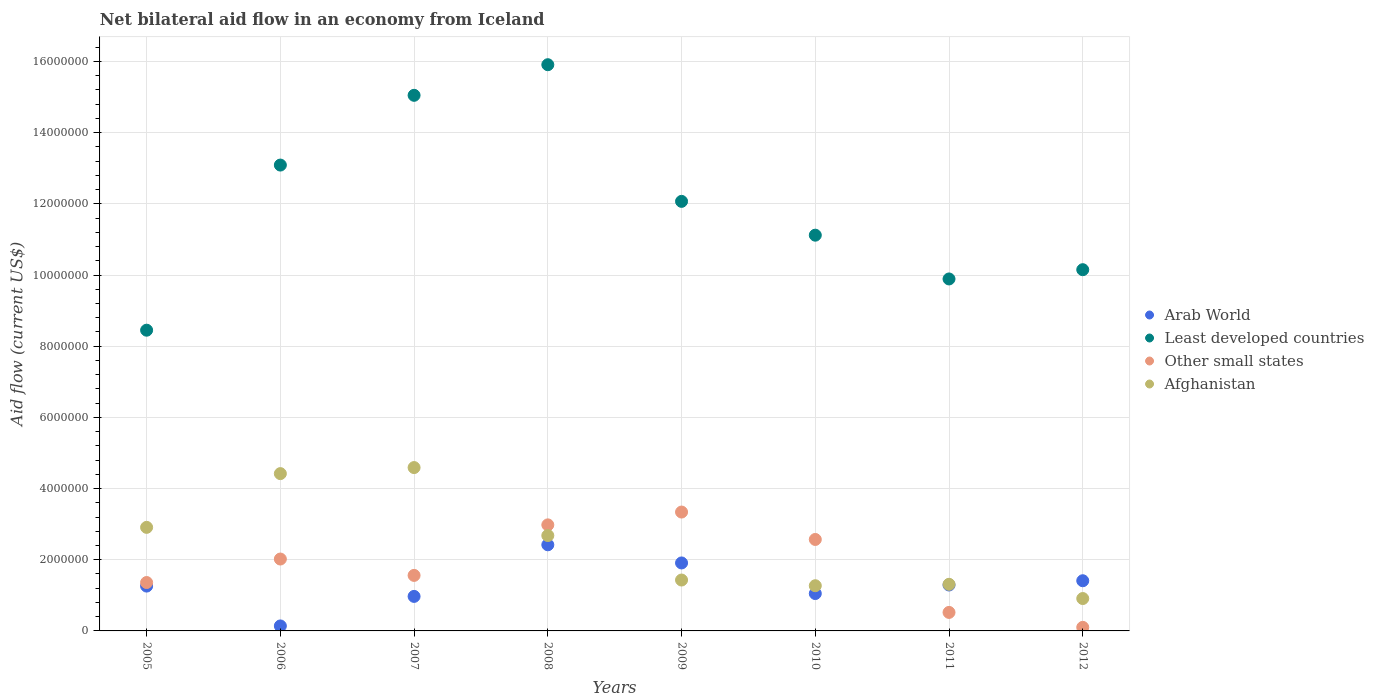How many different coloured dotlines are there?
Make the answer very short. 4. What is the net bilateral aid flow in Other small states in 2008?
Keep it short and to the point. 2.98e+06. Across all years, what is the maximum net bilateral aid flow in Afghanistan?
Keep it short and to the point. 4.59e+06. Across all years, what is the minimum net bilateral aid flow in Other small states?
Your response must be concise. 1.00e+05. In which year was the net bilateral aid flow in Afghanistan minimum?
Give a very brief answer. 2012. What is the total net bilateral aid flow in Other small states in the graph?
Provide a succinct answer. 1.44e+07. What is the difference between the net bilateral aid flow in Other small states in 2005 and that in 2009?
Your answer should be compact. -1.98e+06. What is the difference between the net bilateral aid flow in Afghanistan in 2009 and the net bilateral aid flow in Least developed countries in 2007?
Your response must be concise. -1.36e+07. What is the average net bilateral aid flow in Afghanistan per year?
Your answer should be compact. 2.44e+06. What is the ratio of the net bilateral aid flow in Arab World in 2009 to that in 2012?
Provide a short and direct response. 1.35. What is the difference between the highest and the second highest net bilateral aid flow in Arab World?
Your response must be concise. 5.10e+05. What is the difference between the highest and the lowest net bilateral aid flow in Least developed countries?
Make the answer very short. 7.46e+06. Is the sum of the net bilateral aid flow in Least developed countries in 2008 and 2009 greater than the maximum net bilateral aid flow in Afghanistan across all years?
Keep it short and to the point. Yes. Is it the case that in every year, the sum of the net bilateral aid flow in Other small states and net bilateral aid flow in Arab World  is greater than the sum of net bilateral aid flow in Afghanistan and net bilateral aid flow in Least developed countries?
Keep it short and to the point. No. Is it the case that in every year, the sum of the net bilateral aid flow in Afghanistan and net bilateral aid flow in Arab World  is greater than the net bilateral aid flow in Least developed countries?
Provide a succinct answer. No. Does the net bilateral aid flow in Afghanistan monotonically increase over the years?
Provide a short and direct response. No. Is the net bilateral aid flow in Arab World strictly less than the net bilateral aid flow in Least developed countries over the years?
Ensure brevity in your answer.  Yes. How many dotlines are there?
Offer a very short reply. 4. How many years are there in the graph?
Keep it short and to the point. 8. What is the difference between two consecutive major ticks on the Y-axis?
Your answer should be compact. 2.00e+06. Does the graph contain any zero values?
Provide a succinct answer. No. What is the title of the graph?
Provide a succinct answer. Net bilateral aid flow in an economy from Iceland. What is the label or title of the X-axis?
Give a very brief answer. Years. What is the Aid flow (current US$) in Arab World in 2005?
Your answer should be compact. 1.26e+06. What is the Aid flow (current US$) in Least developed countries in 2005?
Offer a terse response. 8.45e+06. What is the Aid flow (current US$) of Other small states in 2005?
Offer a terse response. 1.36e+06. What is the Aid flow (current US$) of Afghanistan in 2005?
Your answer should be very brief. 2.91e+06. What is the Aid flow (current US$) of Arab World in 2006?
Your answer should be very brief. 1.40e+05. What is the Aid flow (current US$) of Least developed countries in 2006?
Your answer should be compact. 1.31e+07. What is the Aid flow (current US$) of Other small states in 2006?
Your response must be concise. 2.02e+06. What is the Aid flow (current US$) of Afghanistan in 2006?
Provide a succinct answer. 4.42e+06. What is the Aid flow (current US$) of Arab World in 2007?
Your answer should be compact. 9.70e+05. What is the Aid flow (current US$) of Least developed countries in 2007?
Keep it short and to the point. 1.50e+07. What is the Aid flow (current US$) of Other small states in 2007?
Offer a very short reply. 1.56e+06. What is the Aid flow (current US$) of Afghanistan in 2007?
Keep it short and to the point. 4.59e+06. What is the Aid flow (current US$) of Arab World in 2008?
Ensure brevity in your answer.  2.42e+06. What is the Aid flow (current US$) of Least developed countries in 2008?
Provide a short and direct response. 1.59e+07. What is the Aid flow (current US$) in Other small states in 2008?
Keep it short and to the point. 2.98e+06. What is the Aid flow (current US$) in Afghanistan in 2008?
Offer a very short reply. 2.68e+06. What is the Aid flow (current US$) in Arab World in 2009?
Provide a succinct answer. 1.91e+06. What is the Aid flow (current US$) in Least developed countries in 2009?
Provide a succinct answer. 1.21e+07. What is the Aid flow (current US$) of Other small states in 2009?
Keep it short and to the point. 3.34e+06. What is the Aid flow (current US$) in Afghanistan in 2009?
Give a very brief answer. 1.43e+06. What is the Aid flow (current US$) of Arab World in 2010?
Give a very brief answer. 1.05e+06. What is the Aid flow (current US$) of Least developed countries in 2010?
Give a very brief answer. 1.11e+07. What is the Aid flow (current US$) of Other small states in 2010?
Give a very brief answer. 2.57e+06. What is the Aid flow (current US$) in Afghanistan in 2010?
Your response must be concise. 1.27e+06. What is the Aid flow (current US$) in Arab World in 2011?
Ensure brevity in your answer.  1.29e+06. What is the Aid flow (current US$) of Least developed countries in 2011?
Provide a short and direct response. 9.89e+06. What is the Aid flow (current US$) of Other small states in 2011?
Offer a terse response. 5.20e+05. What is the Aid flow (current US$) of Afghanistan in 2011?
Keep it short and to the point. 1.31e+06. What is the Aid flow (current US$) in Arab World in 2012?
Provide a succinct answer. 1.41e+06. What is the Aid flow (current US$) in Least developed countries in 2012?
Give a very brief answer. 1.02e+07. What is the Aid flow (current US$) in Other small states in 2012?
Provide a succinct answer. 1.00e+05. What is the Aid flow (current US$) of Afghanistan in 2012?
Provide a short and direct response. 9.10e+05. Across all years, what is the maximum Aid flow (current US$) of Arab World?
Make the answer very short. 2.42e+06. Across all years, what is the maximum Aid flow (current US$) in Least developed countries?
Your answer should be very brief. 1.59e+07. Across all years, what is the maximum Aid flow (current US$) of Other small states?
Ensure brevity in your answer.  3.34e+06. Across all years, what is the maximum Aid flow (current US$) in Afghanistan?
Make the answer very short. 4.59e+06. Across all years, what is the minimum Aid flow (current US$) of Least developed countries?
Your response must be concise. 8.45e+06. Across all years, what is the minimum Aid flow (current US$) in Other small states?
Provide a short and direct response. 1.00e+05. Across all years, what is the minimum Aid flow (current US$) in Afghanistan?
Your response must be concise. 9.10e+05. What is the total Aid flow (current US$) of Arab World in the graph?
Provide a succinct answer. 1.04e+07. What is the total Aid flow (current US$) of Least developed countries in the graph?
Provide a succinct answer. 9.57e+07. What is the total Aid flow (current US$) of Other small states in the graph?
Give a very brief answer. 1.44e+07. What is the total Aid flow (current US$) in Afghanistan in the graph?
Your answer should be very brief. 1.95e+07. What is the difference between the Aid flow (current US$) of Arab World in 2005 and that in 2006?
Your response must be concise. 1.12e+06. What is the difference between the Aid flow (current US$) in Least developed countries in 2005 and that in 2006?
Your response must be concise. -4.64e+06. What is the difference between the Aid flow (current US$) of Other small states in 2005 and that in 2006?
Make the answer very short. -6.60e+05. What is the difference between the Aid flow (current US$) in Afghanistan in 2005 and that in 2006?
Keep it short and to the point. -1.51e+06. What is the difference between the Aid flow (current US$) in Least developed countries in 2005 and that in 2007?
Provide a succinct answer. -6.60e+06. What is the difference between the Aid flow (current US$) in Afghanistan in 2005 and that in 2007?
Make the answer very short. -1.68e+06. What is the difference between the Aid flow (current US$) of Arab World in 2005 and that in 2008?
Ensure brevity in your answer.  -1.16e+06. What is the difference between the Aid flow (current US$) of Least developed countries in 2005 and that in 2008?
Ensure brevity in your answer.  -7.46e+06. What is the difference between the Aid flow (current US$) in Other small states in 2005 and that in 2008?
Provide a succinct answer. -1.62e+06. What is the difference between the Aid flow (current US$) of Arab World in 2005 and that in 2009?
Give a very brief answer. -6.50e+05. What is the difference between the Aid flow (current US$) in Least developed countries in 2005 and that in 2009?
Give a very brief answer. -3.62e+06. What is the difference between the Aid flow (current US$) of Other small states in 2005 and that in 2009?
Your answer should be very brief. -1.98e+06. What is the difference between the Aid flow (current US$) of Afghanistan in 2005 and that in 2009?
Your answer should be compact. 1.48e+06. What is the difference between the Aid flow (current US$) in Arab World in 2005 and that in 2010?
Your response must be concise. 2.10e+05. What is the difference between the Aid flow (current US$) of Least developed countries in 2005 and that in 2010?
Give a very brief answer. -2.67e+06. What is the difference between the Aid flow (current US$) of Other small states in 2005 and that in 2010?
Give a very brief answer. -1.21e+06. What is the difference between the Aid flow (current US$) of Afghanistan in 2005 and that in 2010?
Provide a short and direct response. 1.64e+06. What is the difference between the Aid flow (current US$) in Arab World in 2005 and that in 2011?
Make the answer very short. -3.00e+04. What is the difference between the Aid flow (current US$) of Least developed countries in 2005 and that in 2011?
Provide a succinct answer. -1.44e+06. What is the difference between the Aid flow (current US$) in Other small states in 2005 and that in 2011?
Your response must be concise. 8.40e+05. What is the difference between the Aid flow (current US$) of Afghanistan in 2005 and that in 2011?
Make the answer very short. 1.60e+06. What is the difference between the Aid flow (current US$) in Least developed countries in 2005 and that in 2012?
Ensure brevity in your answer.  -1.70e+06. What is the difference between the Aid flow (current US$) in Other small states in 2005 and that in 2012?
Your response must be concise. 1.26e+06. What is the difference between the Aid flow (current US$) in Arab World in 2006 and that in 2007?
Offer a very short reply. -8.30e+05. What is the difference between the Aid flow (current US$) in Least developed countries in 2006 and that in 2007?
Offer a very short reply. -1.96e+06. What is the difference between the Aid flow (current US$) in Other small states in 2006 and that in 2007?
Your response must be concise. 4.60e+05. What is the difference between the Aid flow (current US$) in Afghanistan in 2006 and that in 2007?
Your answer should be very brief. -1.70e+05. What is the difference between the Aid flow (current US$) of Arab World in 2006 and that in 2008?
Offer a terse response. -2.28e+06. What is the difference between the Aid flow (current US$) of Least developed countries in 2006 and that in 2008?
Give a very brief answer. -2.82e+06. What is the difference between the Aid flow (current US$) of Other small states in 2006 and that in 2008?
Offer a very short reply. -9.60e+05. What is the difference between the Aid flow (current US$) in Afghanistan in 2006 and that in 2008?
Provide a short and direct response. 1.74e+06. What is the difference between the Aid flow (current US$) in Arab World in 2006 and that in 2009?
Give a very brief answer. -1.77e+06. What is the difference between the Aid flow (current US$) of Least developed countries in 2006 and that in 2009?
Offer a very short reply. 1.02e+06. What is the difference between the Aid flow (current US$) of Other small states in 2006 and that in 2009?
Make the answer very short. -1.32e+06. What is the difference between the Aid flow (current US$) of Afghanistan in 2006 and that in 2009?
Keep it short and to the point. 2.99e+06. What is the difference between the Aid flow (current US$) of Arab World in 2006 and that in 2010?
Provide a succinct answer. -9.10e+05. What is the difference between the Aid flow (current US$) of Least developed countries in 2006 and that in 2010?
Your answer should be compact. 1.97e+06. What is the difference between the Aid flow (current US$) of Other small states in 2006 and that in 2010?
Keep it short and to the point. -5.50e+05. What is the difference between the Aid flow (current US$) in Afghanistan in 2006 and that in 2010?
Offer a very short reply. 3.15e+06. What is the difference between the Aid flow (current US$) in Arab World in 2006 and that in 2011?
Ensure brevity in your answer.  -1.15e+06. What is the difference between the Aid flow (current US$) in Least developed countries in 2006 and that in 2011?
Make the answer very short. 3.20e+06. What is the difference between the Aid flow (current US$) in Other small states in 2006 and that in 2011?
Keep it short and to the point. 1.50e+06. What is the difference between the Aid flow (current US$) of Afghanistan in 2006 and that in 2011?
Give a very brief answer. 3.11e+06. What is the difference between the Aid flow (current US$) of Arab World in 2006 and that in 2012?
Ensure brevity in your answer.  -1.27e+06. What is the difference between the Aid flow (current US$) in Least developed countries in 2006 and that in 2012?
Provide a short and direct response. 2.94e+06. What is the difference between the Aid flow (current US$) of Other small states in 2006 and that in 2012?
Your response must be concise. 1.92e+06. What is the difference between the Aid flow (current US$) in Afghanistan in 2006 and that in 2012?
Ensure brevity in your answer.  3.51e+06. What is the difference between the Aid flow (current US$) in Arab World in 2007 and that in 2008?
Your answer should be compact. -1.45e+06. What is the difference between the Aid flow (current US$) in Least developed countries in 2007 and that in 2008?
Provide a short and direct response. -8.60e+05. What is the difference between the Aid flow (current US$) in Other small states in 2007 and that in 2008?
Your response must be concise. -1.42e+06. What is the difference between the Aid flow (current US$) in Afghanistan in 2007 and that in 2008?
Offer a very short reply. 1.91e+06. What is the difference between the Aid flow (current US$) in Arab World in 2007 and that in 2009?
Offer a very short reply. -9.40e+05. What is the difference between the Aid flow (current US$) of Least developed countries in 2007 and that in 2009?
Offer a terse response. 2.98e+06. What is the difference between the Aid flow (current US$) in Other small states in 2007 and that in 2009?
Ensure brevity in your answer.  -1.78e+06. What is the difference between the Aid flow (current US$) of Afghanistan in 2007 and that in 2009?
Make the answer very short. 3.16e+06. What is the difference between the Aid flow (current US$) in Arab World in 2007 and that in 2010?
Your answer should be very brief. -8.00e+04. What is the difference between the Aid flow (current US$) of Least developed countries in 2007 and that in 2010?
Ensure brevity in your answer.  3.93e+06. What is the difference between the Aid flow (current US$) in Other small states in 2007 and that in 2010?
Give a very brief answer. -1.01e+06. What is the difference between the Aid flow (current US$) in Afghanistan in 2007 and that in 2010?
Your answer should be very brief. 3.32e+06. What is the difference between the Aid flow (current US$) in Arab World in 2007 and that in 2011?
Offer a very short reply. -3.20e+05. What is the difference between the Aid flow (current US$) of Least developed countries in 2007 and that in 2011?
Your answer should be compact. 5.16e+06. What is the difference between the Aid flow (current US$) of Other small states in 2007 and that in 2011?
Your answer should be compact. 1.04e+06. What is the difference between the Aid flow (current US$) of Afghanistan in 2007 and that in 2011?
Offer a very short reply. 3.28e+06. What is the difference between the Aid flow (current US$) in Arab World in 2007 and that in 2012?
Ensure brevity in your answer.  -4.40e+05. What is the difference between the Aid flow (current US$) in Least developed countries in 2007 and that in 2012?
Keep it short and to the point. 4.90e+06. What is the difference between the Aid flow (current US$) in Other small states in 2007 and that in 2012?
Offer a terse response. 1.46e+06. What is the difference between the Aid flow (current US$) of Afghanistan in 2007 and that in 2012?
Your response must be concise. 3.68e+06. What is the difference between the Aid flow (current US$) of Arab World in 2008 and that in 2009?
Offer a terse response. 5.10e+05. What is the difference between the Aid flow (current US$) of Least developed countries in 2008 and that in 2009?
Your response must be concise. 3.84e+06. What is the difference between the Aid flow (current US$) in Other small states in 2008 and that in 2009?
Provide a succinct answer. -3.60e+05. What is the difference between the Aid flow (current US$) in Afghanistan in 2008 and that in 2009?
Offer a terse response. 1.25e+06. What is the difference between the Aid flow (current US$) in Arab World in 2008 and that in 2010?
Provide a succinct answer. 1.37e+06. What is the difference between the Aid flow (current US$) of Least developed countries in 2008 and that in 2010?
Provide a succinct answer. 4.79e+06. What is the difference between the Aid flow (current US$) in Other small states in 2008 and that in 2010?
Provide a succinct answer. 4.10e+05. What is the difference between the Aid flow (current US$) of Afghanistan in 2008 and that in 2010?
Offer a very short reply. 1.41e+06. What is the difference between the Aid flow (current US$) in Arab World in 2008 and that in 2011?
Your answer should be compact. 1.13e+06. What is the difference between the Aid flow (current US$) in Least developed countries in 2008 and that in 2011?
Offer a terse response. 6.02e+06. What is the difference between the Aid flow (current US$) in Other small states in 2008 and that in 2011?
Your response must be concise. 2.46e+06. What is the difference between the Aid flow (current US$) of Afghanistan in 2008 and that in 2011?
Your response must be concise. 1.37e+06. What is the difference between the Aid flow (current US$) in Arab World in 2008 and that in 2012?
Your answer should be compact. 1.01e+06. What is the difference between the Aid flow (current US$) of Least developed countries in 2008 and that in 2012?
Give a very brief answer. 5.76e+06. What is the difference between the Aid flow (current US$) in Other small states in 2008 and that in 2012?
Provide a succinct answer. 2.88e+06. What is the difference between the Aid flow (current US$) of Afghanistan in 2008 and that in 2012?
Your answer should be compact. 1.77e+06. What is the difference between the Aid flow (current US$) of Arab World in 2009 and that in 2010?
Offer a terse response. 8.60e+05. What is the difference between the Aid flow (current US$) in Least developed countries in 2009 and that in 2010?
Your answer should be very brief. 9.50e+05. What is the difference between the Aid flow (current US$) of Other small states in 2009 and that in 2010?
Offer a very short reply. 7.70e+05. What is the difference between the Aid flow (current US$) in Arab World in 2009 and that in 2011?
Offer a very short reply. 6.20e+05. What is the difference between the Aid flow (current US$) of Least developed countries in 2009 and that in 2011?
Your answer should be very brief. 2.18e+06. What is the difference between the Aid flow (current US$) of Other small states in 2009 and that in 2011?
Provide a short and direct response. 2.82e+06. What is the difference between the Aid flow (current US$) of Least developed countries in 2009 and that in 2012?
Keep it short and to the point. 1.92e+06. What is the difference between the Aid flow (current US$) of Other small states in 2009 and that in 2012?
Ensure brevity in your answer.  3.24e+06. What is the difference between the Aid flow (current US$) in Afghanistan in 2009 and that in 2012?
Provide a succinct answer. 5.20e+05. What is the difference between the Aid flow (current US$) in Least developed countries in 2010 and that in 2011?
Offer a terse response. 1.23e+06. What is the difference between the Aid flow (current US$) of Other small states in 2010 and that in 2011?
Provide a short and direct response. 2.05e+06. What is the difference between the Aid flow (current US$) in Arab World in 2010 and that in 2012?
Your answer should be compact. -3.60e+05. What is the difference between the Aid flow (current US$) in Least developed countries in 2010 and that in 2012?
Give a very brief answer. 9.70e+05. What is the difference between the Aid flow (current US$) in Other small states in 2010 and that in 2012?
Your answer should be compact. 2.47e+06. What is the difference between the Aid flow (current US$) in Arab World in 2011 and that in 2012?
Provide a short and direct response. -1.20e+05. What is the difference between the Aid flow (current US$) in Least developed countries in 2011 and that in 2012?
Make the answer very short. -2.60e+05. What is the difference between the Aid flow (current US$) in Other small states in 2011 and that in 2012?
Provide a short and direct response. 4.20e+05. What is the difference between the Aid flow (current US$) of Arab World in 2005 and the Aid flow (current US$) of Least developed countries in 2006?
Offer a terse response. -1.18e+07. What is the difference between the Aid flow (current US$) of Arab World in 2005 and the Aid flow (current US$) of Other small states in 2006?
Make the answer very short. -7.60e+05. What is the difference between the Aid flow (current US$) of Arab World in 2005 and the Aid flow (current US$) of Afghanistan in 2006?
Ensure brevity in your answer.  -3.16e+06. What is the difference between the Aid flow (current US$) of Least developed countries in 2005 and the Aid flow (current US$) of Other small states in 2006?
Keep it short and to the point. 6.43e+06. What is the difference between the Aid flow (current US$) of Least developed countries in 2005 and the Aid flow (current US$) of Afghanistan in 2006?
Make the answer very short. 4.03e+06. What is the difference between the Aid flow (current US$) of Other small states in 2005 and the Aid flow (current US$) of Afghanistan in 2006?
Give a very brief answer. -3.06e+06. What is the difference between the Aid flow (current US$) of Arab World in 2005 and the Aid flow (current US$) of Least developed countries in 2007?
Keep it short and to the point. -1.38e+07. What is the difference between the Aid flow (current US$) in Arab World in 2005 and the Aid flow (current US$) in Other small states in 2007?
Offer a terse response. -3.00e+05. What is the difference between the Aid flow (current US$) in Arab World in 2005 and the Aid flow (current US$) in Afghanistan in 2007?
Offer a terse response. -3.33e+06. What is the difference between the Aid flow (current US$) of Least developed countries in 2005 and the Aid flow (current US$) of Other small states in 2007?
Provide a succinct answer. 6.89e+06. What is the difference between the Aid flow (current US$) of Least developed countries in 2005 and the Aid flow (current US$) of Afghanistan in 2007?
Your response must be concise. 3.86e+06. What is the difference between the Aid flow (current US$) of Other small states in 2005 and the Aid flow (current US$) of Afghanistan in 2007?
Keep it short and to the point. -3.23e+06. What is the difference between the Aid flow (current US$) of Arab World in 2005 and the Aid flow (current US$) of Least developed countries in 2008?
Make the answer very short. -1.46e+07. What is the difference between the Aid flow (current US$) in Arab World in 2005 and the Aid flow (current US$) in Other small states in 2008?
Your answer should be very brief. -1.72e+06. What is the difference between the Aid flow (current US$) in Arab World in 2005 and the Aid flow (current US$) in Afghanistan in 2008?
Your answer should be very brief. -1.42e+06. What is the difference between the Aid flow (current US$) of Least developed countries in 2005 and the Aid flow (current US$) of Other small states in 2008?
Offer a terse response. 5.47e+06. What is the difference between the Aid flow (current US$) in Least developed countries in 2005 and the Aid flow (current US$) in Afghanistan in 2008?
Offer a very short reply. 5.77e+06. What is the difference between the Aid flow (current US$) of Other small states in 2005 and the Aid flow (current US$) of Afghanistan in 2008?
Offer a very short reply. -1.32e+06. What is the difference between the Aid flow (current US$) of Arab World in 2005 and the Aid flow (current US$) of Least developed countries in 2009?
Keep it short and to the point. -1.08e+07. What is the difference between the Aid flow (current US$) of Arab World in 2005 and the Aid flow (current US$) of Other small states in 2009?
Your answer should be compact. -2.08e+06. What is the difference between the Aid flow (current US$) of Least developed countries in 2005 and the Aid flow (current US$) of Other small states in 2009?
Offer a terse response. 5.11e+06. What is the difference between the Aid flow (current US$) in Least developed countries in 2005 and the Aid flow (current US$) in Afghanistan in 2009?
Provide a short and direct response. 7.02e+06. What is the difference between the Aid flow (current US$) of Other small states in 2005 and the Aid flow (current US$) of Afghanistan in 2009?
Your response must be concise. -7.00e+04. What is the difference between the Aid flow (current US$) of Arab World in 2005 and the Aid flow (current US$) of Least developed countries in 2010?
Keep it short and to the point. -9.86e+06. What is the difference between the Aid flow (current US$) in Arab World in 2005 and the Aid flow (current US$) in Other small states in 2010?
Ensure brevity in your answer.  -1.31e+06. What is the difference between the Aid flow (current US$) in Least developed countries in 2005 and the Aid flow (current US$) in Other small states in 2010?
Your answer should be compact. 5.88e+06. What is the difference between the Aid flow (current US$) in Least developed countries in 2005 and the Aid flow (current US$) in Afghanistan in 2010?
Provide a short and direct response. 7.18e+06. What is the difference between the Aid flow (current US$) in Other small states in 2005 and the Aid flow (current US$) in Afghanistan in 2010?
Keep it short and to the point. 9.00e+04. What is the difference between the Aid flow (current US$) of Arab World in 2005 and the Aid flow (current US$) of Least developed countries in 2011?
Your response must be concise. -8.63e+06. What is the difference between the Aid flow (current US$) in Arab World in 2005 and the Aid flow (current US$) in Other small states in 2011?
Provide a succinct answer. 7.40e+05. What is the difference between the Aid flow (current US$) in Arab World in 2005 and the Aid flow (current US$) in Afghanistan in 2011?
Ensure brevity in your answer.  -5.00e+04. What is the difference between the Aid flow (current US$) of Least developed countries in 2005 and the Aid flow (current US$) of Other small states in 2011?
Your answer should be very brief. 7.93e+06. What is the difference between the Aid flow (current US$) in Least developed countries in 2005 and the Aid flow (current US$) in Afghanistan in 2011?
Give a very brief answer. 7.14e+06. What is the difference between the Aid flow (current US$) in Other small states in 2005 and the Aid flow (current US$) in Afghanistan in 2011?
Make the answer very short. 5.00e+04. What is the difference between the Aid flow (current US$) of Arab World in 2005 and the Aid flow (current US$) of Least developed countries in 2012?
Your response must be concise. -8.89e+06. What is the difference between the Aid flow (current US$) in Arab World in 2005 and the Aid flow (current US$) in Other small states in 2012?
Provide a succinct answer. 1.16e+06. What is the difference between the Aid flow (current US$) of Least developed countries in 2005 and the Aid flow (current US$) of Other small states in 2012?
Offer a very short reply. 8.35e+06. What is the difference between the Aid flow (current US$) in Least developed countries in 2005 and the Aid flow (current US$) in Afghanistan in 2012?
Your answer should be very brief. 7.54e+06. What is the difference between the Aid flow (current US$) of Arab World in 2006 and the Aid flow (current US$) of Least developed countries in 2007?
Ensure brevity in your answer.  -1.49e+07. What is the difference between the Aid flow (current US$) of Arab World in 2006 and the Aid flow (current US$) of Other small states in 2007?
Offer a very short reply. -1.42e+06. What is the difference between the Aid flow (current US$) of Arab World in 2006 and the Aid flow (current US$) of Afghanistan in 2007?
Keep it short and to the point. -4.45e+06. What is the difference between the Aid flow (current US$) of Least developed countries in 2006 and the Aid flow (current US$) of Other small states in 2007?
Keep it short and to the point. 1.15e+07. What is the difference between the Aid flow (current US$) in Least developed countries in 2006 and the Aid flow (current US$) in Afghanistan in 2007?
Offer a very short reply. 8.50e+06. What is the difference between the Aid flow (current US$) in Other small states in 2006 and the Aid flow (current US$) in Afghanistan in 2007?
Give a very brief answer. -2.57e+06. What is the difference between the Aid flow (current US$) in Arab World in 2006 and the Aid flow (current US$) in Least developed countries in 2008?
Offer a terse response. -1.58e+07. What is the difference between the Aid flow (current US$) in Arab World in 2006 and the Aid flow (current US$) in Other small states in 2008?
Give a very brief answer. -2.84e+06. What is the difference between the Aid flow (current US$) in Arab World in 2006 and the Aid flow (current US$) in Afghanistan in 2008?
Make the answer very short. -2.54e+06. What is the difference between the Aid flow (current US$) of Least developed countries in 2006 and the Aid flow (current US$) of Other small states in 2008?
Your answer should be very brief. 1.01e+07. What is the difference between the Aid flow (current US$) in Least developed countries in 2006 and the Aid flow (current US$) in Afghanistan in 2008?
Make the answer very short. 1.04e+07. What is the difference between the Aid flow (current US$) of Other small states in 2006 and the Aid flow (current US$) of Afghanistan in 2008?
Provide a succinct answer. -6.60e+05. What is the difference between the Aid flow (current US$) of Arab World in 2006 and the Aid flow (current US$) of Least developed countries in 2009?
Ensure brevity in your answer.  -1.19e+07. What is the difference between the Aid flow (current US$) in Arab World in 2006 and the Aid flow (current US$) in Other small states in 2009?
Keep it short and to the point. -3.20e+06. What is the difference between the Aid flow (current US$) in Arab World in 2006 and the Aid flow (current US$) in Afghanistan in 2009?
Offer a terse response. -1.29e+06. What is the difference between the Aid flow (current US$) in Least developed countries in 2006 and the Aid flow (current US$) in Other small states in 2009?
Your response must be concise. 9.75e+06. What is the difference between the Aid flow (current US$) of Least developed countries in 2006 and the Aid flow (current US$) of Afghanistan in 2009?
Provide a short and direct response. 1.17e+07. What is the difference between the Aid flow (current US$) in Other small states in 2006 and the Aid flow (current US$) in Afghanistan in 2009?
Offer a very short reply. 5.90e+05. What is the difference between the Aid flow (current US$) of Arab World in 2006 and the Aid flow (current US$) of Least developed countries in 2010?
Your answer should be very brief. -1.10e+07. What is the difference between the Aid flow (current US$) in Arab World in 2006 and the Aid flow (current US$) in Other small states in 2010?
Your response must be concise. -2.43e+06. What is the difference between the Aid flow (current US$) of Arab World in 2006 and the Aid flow (current US$) of Afghanistan in 2010?
Your response must be concise. -1.13e+06. What is the difference between the Aid flow (current US$) in Least developed countries in 2006 and the Aid flow (current US$) in Other small states in 2010?
Provide a short and direct response. 1.05e+07. What is the difference between the Aid flow (current US$) in Least developed countries in 2006 and the Aid flow (current US$) in Afghanistan in 2010?
Keep it short and to the point. 1.18e+07. What is the difference between the Aid flow (current US$) in Other small states in 2006 and the Aid flow (current US$) in Afghanistan in 2010?
Offer a terse response. 7.50e+05. What is the difference between the Aid flow (current US$) in Arab World in 2006 and the Aid flow (current US$) in Least developed countries in 2011?
Offer a terse response. -9.75e+06. What is the difference between the Aid flow (current US$) in Arab World in 2006 and the Aid flow (current US$) in Other small states in 2011?
Give a very brief answer. -3.80e+05. What is the difference between the Aid flow (current US$) in Arab World in 2006 and the Aid flow (current US$) in Afghanistan in 2011?
Ensure brevity in your answer.  -1.17e+06. What is the difference between the Aid flow (current US$) in Least developed countries in 2006 and the Aid flow (current US$) in Other small states in 2011?
Your response must be concise. 1.26e+07. What is the difference between the Aid flow (current US$) of Least developed countries in 2006 and the Aid flow (current US$) of Afghanistan in 2011?
Your response must be concise. 1.18e+07. What is the difference between the Aid flow (current US$) of Other small states in 2006 and the Aid flow (current US$) of Afghanistan in 2011?
Offer a terse response. 7.10e+05. What is the difference between the Aid flow (current US$) in Arab World in 2006 and the Aid flow (current US$) in Least developed countries in 2012?
Your response must be concise. -1.00e+07. What is the difference between the Aid flow (current US$) of Arab World in 2006 and the Aid flow (current US$) of Afghanistan in 2012?
Give a very brief answer. -7.70e+05. What is the difference between the Aid flow (current US$) in Least developed countries in 2006 and the Aid flow (current US$) in Other small states in 2012?
Give a very brief answer. 1.30e+07. What is the difference between the Aid flow (current US$) of Least developed countries in 2006 and the Aid flow (current US$) of Afghanistan in 2012?
Ensure brevity in your answer.  1.22e+07. What is the difference between the Aid flow (current US$) of Other small states in 2006 and the Aid flow (current US$) of Afghanistan in 2012?
Your answer should be very brief. 1.11e+06. What is the difference between the Aid flow (current US$) in Arab World in 2007 and the Aid flow (current US$) in Least developed countries in 2008?
Provide a short and direct response. -1.49e+07. What is the difference between the Aid flow (current US$) of Arab World in 2007 and the Aid flow (current US$) of Other small states in 2008?
Your answer should be compact. -2.01e+06. What is the difference between the Aid flow (current US$) of Arab World in 2007 and the Aid flow (current US$) of Afghanistan in 2008?
Your answer should be very brief. -1.71e+06. What is the difference between the Aid flow (current US$) of Least developed countries in 2007 and the Aid flow (current US$) of Other small states in 2008?
Keep it short and to the point. 1.21e+07. What is the difference between the Aid flow (current US$) of Least developed countries in 2007 and the Aid flow (current US$) of Afghanistan in 2008?
Offer a very short reply. 1.24e+07. What is the difference between the Aid flow (current US$) in Other small states in 2007 and the Aid flow (current US$) in Afghanistan in 2008?
Your response must be concise. -1.12e+06. What is the difference between the Aid flow (current US$) in Arab World in 2007 and the Aid flow (current US$) in Least developed countries in 2009?
Offer a terse response. -1.11e+07. What is the difference between the Aid flow (current US$) in Arab World in 2007 and the Aid flow (current US$) in Other small states in 2009?
Your answer should be compact. -2.37e+06. What is the difference between the Aid flow (current US$) of Arab World in 2007 and the Aid flow (current US$) of Afghanistan in 2009?
Your response must be concise. -4.60e+05. What is the difference between the Aid flow (current US$) of Least developed countries in 2007 and the Aid flow (current US$) of Other small states in 2009?
Give a very brief answer. 1.17e+07. What is the difference between the Aid flow (current US$) of Least developed countries in 2007 and the Aid flow (current US$) of Afghanistan in 2009?
Provide a succinct answer. 1.36e+07. What is the difference between the Aid flow (current US$) in Other small states in 2007 and the Aid flow (current US$) in Afghanistan in 2009?
Offer a very short reply. 1.30e+05. What is the difference between the Aid flow (current US$) of Arab World in 2007 and the Aid flow (current US$) of Least developed countries in 2010?
Ensure brevity in your answer.  -1.02e+07. What is the difference between the Aid flow (current US$) of Arab World in 2007 and the Aid flow (current US$) of Other small states in 2010?
Your response must be concise. -1.60e+06. What is the difference between the Aid flow (current US$) in Arab World in 2007 and the Aid flow (current US$) in Afghanistan in 2010?
Your answer should be very brief. -3.00e+05. What is the difference between the Aid flow (current US$) of Least developed countries in 2007 and the Aid flow (current US$) of Other small states in 2010?
Ensure brevity in your answer.  1.25e+07. What is the difference between the Aid flow (current US$) in Least developed countries in 2007 and the Aid flow (current US$) in Afghanistan in 2010?
Ensure brevity in your answer.  1.38e+07. What is the difference between the Aid flow (current US$) in Arab World in 2007 and the Aid flow (current US$) in Least developed countries in 2011?
Your answer should be very brief. -8.92e+06. What is the difference between the Aid flow (current US$) of Arab World in 2007 and the Aid flow (current US$) of Afghanistan in 2011?
Ensure brevity in your answer.  -3.40e+05. What is the difference between the Aid flow (current US$) in Least developed countries in 2007 and the Aid flow (current US$) in Other small states in 2011?
Give a very brief answer. 1.45e+07. What is the difference between the Aid flow (current US$) in Least developed countries in 2007 and the Aid flow (current US$) in Afghanistan in 2011?
Your response must be concise. 1.37e+07. What is the difference between the Aid flow (current US$) in Other small states in 2007 and the Aid flow (current US$) in Afghanistan in 2011?
Ensure brevity in your answer.  2.50e+05. What is the difference between the Aid flow (current US$) in Arab World in 2007 and the Aid flow (current US$) in Least developed countries in 2012?
Keep it short and to the point. -9.18e+06. What is the difference between the Aid flow (current US$) in Arab World in 2007 and the Aid flow (current US$) in Other small states in 2012?
Your answer should be compact. 8.70e+05. What is the difference between the Aid flow (current US$) in Least developed countries in 2007 and the Aid flow (current US$) in Other small states in 2012?
Provide a short and direct response. 1.50e+07. What is the difference between the Aid flow (current US$) of Least developed countries in 2007 and the Aid flow (current US$) of Afghanistan in 2012?
Provide a succinct answer. 1.41e+07. What is the difference between the Aid flow (current US$) of Other small states in 2007 and the Aid flow (current US$) of Afghanistan in 2012?
Provide a succinct answer. 6.50e+05. What is the difference between the Aid flow (current US$) in Arab World in 2008 and the Aid flow (current US$) in Least developed countries in 2009?
Offer a terse response. -9.65e+06. What is the difference between the Aid flow (current US$) of Arab World in 2008 and the Aid flow (current US$) of Other small states in 2009?
Ensure brevity in your answer.  -9.20e+05. What is the difference between the Aid flow (current US$) in Arab World in 2008 and the Aid flow (current US$) in Afghanistan in 2009?
Keep it short and to the point. 9.90e+05. What is the difference between the Aid flow (current US$) in Least developed countries in 2008 and the Aid flow (current US$) in Other small states in 2009?
Give a very brief answer. 1.26e+07. What is the difference between the Aid flow (current US$) of Least developed countries in 2008 and the Aid flow (current US$) of Afghanistan in 2009?
Your answer should be very brief. 1.45e+07. What is the difference between the Aid flow (current US$) in Other small states in 2008 and the Aid flow (current US$) in Afghanistan in 2009?
Offer a terse response. 1.55e+06. What is the difference between the Aid flow (current US$) of Arab World in 2008 and the Aid flow (current US$) of Least developed countries in 2010?
Ensure brevity in your answer.  -8.70e+06. What is the difference between the Aid flow (current US$) in Arab World in 2008 and the Aid flow (current US$) in Afghanistan in 2010?
Your response must be concise. 1.15e+06. What is the difference between the Aid flow (current US$) of Least developed countries in 2008 and the Aid flow (current US$) of Other small states in 2010?
Offer a very short reply. 1.33e+07. What is the difference between the Aid flow (current US$) of Least developed countries in 2008 and the Aid flow (current US$) of Afghanistan in 2010?
Offer a very short reply. 1.46e+07. What is the difference between the Aid flow (current US$) of Other small states in 2008 and the Aid flow (current US$) of Afghanistan in 2010?
Offer a very short reply. 1.71e+06. What is the difference between the Aid flow (current US$) of Arab World in 2008 and the Aid flow (current US$) of Least developed countries in 2011?
Your response must be concise. -7.47e+06. What is the difference between the Aid flow (current US$) in Arab World in 2008 and the Aid flow (current US$) in Other small states in 2011?
Provide a short and direct response. 1.90e+06. What is the difference between the Aid flow (current US$) in Arab World in 2008 and the Aid flow (current US$) in Afghanistan in 2011?
Provide a succinct answer. 1.11e+06. What is the difference between the Aid flow (current US$) in Least developed countries in 2008 and the Aid flow (current US$) in Other small states in 2011?
Give a very brief answer. 1.54e+07. What is the difference between the Aid flow (current US$) of Least developed countries in 2008 and the Aid flow (current US$) of Afghanistan in 2011?
Your response must be concise. 1.46e+07. What is the difference between the Aid flow (current US$) in Other small states in 2008 and the Aid flow (current US$) in Afghanistan in 2011?
Keep it short and to the point. 1.67e+06. What is the difference between the Aid flow (current US$) in Arab World in 2008 and the Aid flow (current US$) in Least developed countries in 2012?
Your answer should be compact. -7.73e+06. What is the difference between the Aid flow (current US$) of Arab World in 2008 and the Aid flow (current US$) of Other small states in 2012?
Offer a terse response. 2.32e+06. What is the difference between the Aid flow (current US$) of Arab World in 2008 and the Aid flow (current US$) of Afghanistan in 2012?
Provide a short and direct response. 1.51e+06. What is the difference between the Aid flow (current US$) in Least developed countries in 2008 and the Aid flow (current US$) in Other small states in 2012?
Offer a terse response. 1.58e+07. What is the difference between the Aid flow (current US$) of Least developed countries in 2008 and the Aid flow (current US$) of Afghanistan in 2012?
Make the answer very short. 1.50e+07. What is the difference between the Aid flow (current US$) of Other small states in 2008 and the Aid flow (current US$) of Afghanistan in 2012?
Give a very brief answer. 2.07e+06. What is the difference between the Aid flow (current US$) in Arab World in 2009 and the Aid flow (current US$) in Least developed countries in 2010?
Keep it short and to the point. -9.21e+06. What is the difference between the Aid flow (current US$) of Arab World in 2009 and the Aid flow (current US$) of Other small states in 2010?
Give a very brief answer. -6.60e+05. What is the difference between the Aid flow (current US$) in Arab World in 2009 and the Aid flow (current US$) in Afghanistan in 2010?
Offer a very short reply. 6.40e+05. What is the difference between the Aid flow (current US$) in Least developed countries in 2009 and the Aid flow (current US$) in Other small states in 2010?
Ensure brevity in your answer.  9.50e+06. What is the difference between the Aid flow (current US$) of Least developed countries in 2009 and the Aid flow (current US$) of Afghanistan in 2010?
Your answer should be very brief. 1.08e+07. What is the difference between the Aid flow (current US$) in Other small states in 2009 and the Aid flow (current US$) in Afghanistan in 2010?
Provide a succinct answer. 2.07e+06. What is the difference between the Aid flow (current US$) of Arab World in 2009 and the Aid flow (current US$) of Least developed countries in 2011?
Keep it short and to the point. -7.98e+06. What is the difference between the Aid flow (current US$) of Arab World in 2009 and the Aid flow (current US$) of Other small states in 2011?
Offer a very short reply. 1.39e+06. What is the difference between the Aid flow (current US$) in Arab World in 2009 and the Aid flow (current US$) in Afghanistan in 2011?
Your answer should be very brief. 6.00e+05. What is the difference between the Aid flow (current US$) in Least developed countries in 2009 and the Aid flow (current US$) in Other small states in 2011?
Your answer should be very brief. 1.16e+07. What is the difference between the Aid flow (current US$) of Least developed countries in 2009 and the Aid flow (current US$) of Afghanistan in 2011?
Your answer should be very brief. 1.08e+07. What is the difference between the Aid flow (current US$) of Other small states in 2009 and the Aid flow (current US$) of Afghanistan in 2011?
Keep it short and to the point. 2.03e+06. What is the difference between the Aid flow (current US$) in Arab World in 2009 and the Aid flow (current US$) in Least developed countries in 2012?
Offer a terse response. -8.24e+06. What is the difference between the Aid flow (current US$) of Arab World in 2009 and the Aid flow (current US$) of Other small states in 2012?
Give a very brief answer. 1.81e+06. What is the difference between the Aid flow (current US$) of Arab World in 2009 and the Aid flow (current US$) of Afghanistan in 2012?
Keep it short and to the point. 1.00e+06. What is the difference between the Aid flow (current US$) in Least developed countries in 2009 and the Aid flow (current US$) in Other small states in 2012?
Offer a very short reply. 1.20e+07. What is the difference between the Aid flow (current US$) in Least developed countries in 2009 and the Aid flow (current US$) in Afghanistan in 2012?
Give a very brief answer. 1.12e+07. What is the difference between the Aid flow (current US$) in Other small states in 2009 and the Aid flow (current US$) in Afghanistan in 2012?
Offer a terse response. 2.43e+06. What is the difference between the Aid flow (current US$) in Arab World in 2010 and the Aid flow (current US$) in Least developed countries in 2011?
Ensure brevity in your answer.  -8.84e+06. What is the difference between the Aid flow (current US$) of Arab World in 2010 and the Aid flow (current US$) of Other small states in 2011?
Your answer should be very brief. 5.30e+05. What is the difference between the Aid flow (current US$) of Arab World in 2010 and the Aid flow (current US$) of Afghanistan in 2011?
Your answer should be very brief. -2.60e+05. What is the difference between the Aid flow (current US$) in Least developed countries in 2010 and the Aid flow (current US$) in Other small states in 2011?
Offer a very short reply. 1.06e+07. What is the difference between the Aid flow (current US$) of Least developed countries in 2010 and the Aid flow (current US$) of Afghanistan in 2011?
Your answer should be very brief. 9.81e+06. What is the difference between the Aid flow (current US$) of Other small states in 2010 and the Aid flow (current US$) of Afghanistan in 2011?
Offer a very short reply. 1.26e+06. What is the difference between the Aid flow (current US$) in Arab World in 2010 and the Aid flow (current US$) in Least developed countries in 2012?
Offer a terse response. -9.10e+06. What is the difference between the Aid flow (current US$) in Arab World in 2010 and the Aid flow (current US$) in Other small states in 2012?
Ensure brevity in your answer.  9.50e+05. What is the difference between the Aid flow (current US$) of Least developed countries in 2010 and the Aid flow (current US$) of Other small states in 2012?
Provide a succinct answer. 1.10e+07. What is the difference between the Aid flow (current US$) in Least developed countries in 2010 and the Aid flow (current US$) in Afghanistan in 2012?
Your response must be concise. 1.02e+07. What is the difference between the Aid flow (current US$) of Other small states in 2010 and the Aid flow (current US$) of Afghanistan in 2012?
Give a very brief answer. 1.66e+06. What is the difference between the Aid flow (current US$) in Arab World in 2011 and the Aid flow (current US$) in Least developed countries in 2012?
Your response must be concise. -8.86e+06. What is the difference between the Aid flow (current US$) of Arab World in 2011 and the Aid flow (current US$) of Other small states in 2012?
Your answer should be very brief. 1.19e+06. What is the difference between the Aid flow (current US$) of Arab World in 2011 and the Aid flow (current US$) of Afghanistan in 2012?
Your response must be concise. 3.80e+05. What is the difference between the Aid flow (current US$) in Least developed countries in 2011 and the Aid flow (current US$) in Other small states in 2012?
Provide a short and direct response. 9.79e+06. What is the difference between the Aid flow (current US$) of Least developed countries in 2011 and the Aid flow (current US$) of Afghanistan in 2012?
Provide a succinct answer. 8.98e+06. What is the difference between the Aid flow (current US$) of Other small states in 2011 and the Aid flow (current US$) of Afghanistan in 2012?
Your answer should be compact. -3.90e+05. What is the average Aid flow (current US$) in Arab World per year?
Ensure brevity in your answer.  1.31e+06. What is the average Aid flow (current US$) of Least developed countries per year?
Make the answer very short. 1.20e+07. What is the average Aid flow (current US$) of Other small states per year?
Your response must be concise. 1.81e+06. What is the average Aid flow (current US$) in Afghanistan per year?
Make the answer very short. 2.44e+06. In the year 2005, what is the difference between the Aid flow (current US$) of Arab World and Aid flow (current US$) of Least developed countries?
Make the answer very short. -7.19e+06. In the year 2005, what is the difference between the Aid flow (current US$) in Arab World and Aid flow (current US$) in Afghanistan?
Offer a very short reply. -1.65e+06. In the year 2005, what is the difference between the Aid flow (current US$) in Least developed countries and Aid flow (current US$) in Other small states?
Offer a terse response. 7.09e+06. In the year 2005, what is the difference between the Aid flow (current US$) of Least developed countries and Aid flow (current US$) of Afghanistan?
Ensure brevity in your answer.  5.54e+06. In the year 2005, what is the difference between the Aid flow (current US$) of Other small states and Aid flow (current US$) of Afghanistan?
Keep it short and to the point. -1.55e+06. In the year 2006, what is the difference between the Aid flow (current US$) of Arab World and Aid flow (current US$) of Least developed countries?
Give a very brief answer. -1.30e+07. In the year 2006, what is the difference between the Aid flow (current US$) in Arab World and Aid flow (current US$) in Other small states?
Give a very brief answer. -1.88e+06. In the year 2006, what is the difference between the Aid flow (current US$) in Arab World and Aid flow (current US$) in Afghanistan?
Provide a succinct answer. -4.28e+06. In the year 2006, what is the difference between the Aid flow (current US$) of Least developed countries and Aid flow (current US$) of Other small states?
Provide a short and direct response. 1.11e+07. In the year 2006, what is the difference between the Aid flow (current US$) of Least developed countries and Aid flow (current US$) of Afghanistan?
Ensure brevity in your answer.  8.67e+06. In the year 2006, what is the difference between the Aid flow (current US$) of Other small states and Aid flow (current US$) of Afghanistan?
Provide a short and direct response. -2.40e+06. In the year 2007, what is the difference between the Aid flow (current US$) of Arab World and Aid flow (current US$) of Least developed countries?
Ensure brevity in your answer.  -1.41e+07. In the year 2007, what is the difference between the Aid flow (current US$) of Arab World and Aid flow (current US$) of Other small states?
Your answer should be compact. -5.90e+05. In the year 2007, what is the difference between the Aid flow (current US$) of Arab World and Aid flow (current US$) of Afghanistan?
Your response must be concise. -3.62e+06. In the year 2007, what is the difference between the Aid flow (current US$) in Least developed countries and Aid flow (current US$) in Other small states?
Offer a terse response. 1.35e+07. In the year 2007, what is the difference between the Aid flow (current US$) in Least developed countries and Aid flow (current US$) in Afghanistan?
Provide a short and direct response. 1.05e+07. In the year 2007, what is the difference between the Aid flow (current US$) in Other small states and Aid flow (current US$) in Afghanistan?
Give a very brief answer. -3.03e+06. In the year 2008, what is the difference between the Aid flow (current US$) of Arab World and Aid flow (current US$) of Least developed countries?
Give a very brief answer. -1.35e+07. In the year 2008, what is the difference between the Aid flow (current US$) of Arab World and Aid flow (current US$) of Other small states?
Provide a succinct answer. -5.60e+05. In the year 2008, what is the difference between the Aid flow (current US$) in Least developed countries and Aid flow (current US$) in Other small states?
Ensure brevity in your answer.  1.29e+07. In the year 2008, what is the difference between the Aid flow (current US$) of Least developed countries and Aid flow (current US$) of Afghanistan?
Provide a short and direct response. 1.32e+07. In the year 2008, what is the difference between the Aid flow (current US$) in Other small states and Aid flow (current US$) in Afghanistan?
Give a very brief answer. 3.00e+05. In the year 2009, what is the difference between the Aid flow (current US$) in Arab World and Aid flow (current US$) in Least developed countries?
Make the answer very short. -1.02e+07. In the year 2009, what is the difference between the Aid flow (current US$) in Arab World and Aid flow (current US$) in Other small states?
Your response must be concise. -1.43e+06. In the year 2009, what is the difference between the Aid flow (current US$) in Least developed countries and Aid flow (current US$) in Other small states?
Make the answer very short. 8.73e+06. In the year 2009, what is the difference between the Aid flow (current US$) in Least developed countries and Aid flow (current US$) in Afghanistan?
Give a very brief answer. 1.06e+07. In the year 2009, what is the difference between the Aid flow (current US$) in Other small states and Aid flow (current US$) in Afghanistan?
Your response must be concise. 1.91e+06. In the year 2010, what is the difference between the Aid flow (current US$) in Arab World and Aid flow (current US$) in Least developed countries?
Keep it short and to the point. -1.01e+07. In the year 2010, what is the difference between the Aid flow (current US$) in Arab World and Aid flow (current US$) in Other small states?
Keep it short and to the point. -1.52e+06. In the year 2010, what is the difference between the Aid flow (current US$) in Arab World and Aid flow (current US$) in Afghanistan?
Offer a very short reply. -2.20e+05. In the year 2010, what is the difference between the Aid flow (current US$) of Least developed countries and Aid flow (current US$) of Other small states?
Provide a short and direct response. 8.55e+06. In the year 2010, what is the difference between the Aid flow (current US$) in Least developed countries and Aid flow (current US$) in Afghanistan?
Ensure brevity in your answer.  9.85e+06. In the year 2010, what is the difference between the Aid flow (current US$) of Other small states and Aid flow (current US$) of Afghanistan?
Give a very brief answer. 1.30e+06. In the year 2011, what is the difference between the Aid flow (current US$) of Arab World and Aid flow (current US$) of Least developed countries?
Your response must be concise. -8.60e+06. In the year 2011, what is the difference between the Aid flow (current US$) of Arab World and Aid flow (current US$) of Other small states?
Your answer should be very brief. 7.70e+05. In the year 2011, what is the difference between the Aid flow (current US$) in Arab World and Aid flow (current US$) in Afghanistan?
Provide a succinct answer. -2.00e+04. In the year 2011, what is the difference between the Aid flow (current US$) in Least developed countries and Aid flow (current US$) in Other small states?
Provide a short and direct response. 9.37e+06. In the year 2011, what is the difference between the Aid flow (current US$) of Least developed countries and Aid flow (current US$) of Afghanistan?
Make the answer very short. 8.58e+06. In the year 2011, what is the difference between the Aid flow (current US$) of Other small states and Aid flow (current US$) of Afghanistan?
Ensure brevity in your answer.  -7.90e+05. In the year 2012, what is the difference between the Aid flow (current US$) of Arab World and Aid flow (current US$) of Least developed countries?
Offer a very short reply. -8.74e+06. In the year 2012, what is the difference between the Aid flow (current US$) of Arab World and Aid flow (current US$) of Other small states?
Ensure brevity in your answer.  1.31e+06. In the year 2012, what is the difference between the Aid flow (current US$) of Least developed countries and Aid flow (current US$) of Other small states?
Offer a terse response. 1.00e+07. In the year 2012, what is the difference between the Aid flow (current US$) in Least developed countries and Aid flow (current US$) in Afghanistan?
Offer a very short reply. 9.24e+06. In the year 2012, what is the difference between the Aid flow (current US$) of Other small states and Aid flow (current US$) of Afghanistan?
Make the answer very short. -8.10e+05. What is the ratio of the Aid flow (current US$) in Arab World in 2005 to that in 2006?
Your answer should be very brief. 9. What is the ratio of the Aid flow (current US$) in Least developed countries in 2005 to that in 2006?
Your response must be concise. 0.65. What is the ratio of the Aid flow (current US$) of Other small states in 2005 to that in 2006?
Your answer should be very brief. 0.67. What is the ratio of the Aid flow (current US$) in Afghanistan in 2005 to that in 2006?
Your answer should be very brief. 0.66. What is the ratio of the Aid flow (current US$) of Arab World in 2005 to that in 2007?
Keep it short and to the point. 1.3. What is the ratio of the Aid flow (current US$) of Least developed countries in 2005 to that in 2007?
Ensure brevity in your answer.  0.56. What is the ratio of the Aid flow (current US$) of Other small states in 2005 to that in 2007?
Offer a very short reply. 0.87. What is the ratio of the Aid flow (current US$) in Afghanistan in 2005 to that in 2007?
Your response must be concise. 0.63. What is the ratio of the Aid flow (current US$) in Arab World in 2005 to that in 2008?
Provide a succinct answer. 0.52. What is the ratio of the Aid flow (current US$) in Least developed countries in 2005 to that in 2008?
Make the answer very short. 0.53. What is the ratio of the Aid flow (current US$) in Other small states in 2005 to that in 2008?
Ensure brevity in your answer.  0.46. What is the ratio of the Aid flow (current US$) in Afghanistan in 2005 to that in 2008?
Ensure brevity in your answer.  1.09. What is the ratio of the Aid flow (current US$) in Arab World in 2005 to that in 2009?
Your answer should be compact. 0.66. What is the ratio of the Aid flow (current US$) in Least developed countries in 2005 to that in 2009?
Offer a very short reply. 0.7. What is the ratio of the Aid flow (current US$) in Other small states in 2005 to that in 2009?
Make the answer very short. 0.41. What is the ratio of the Aid flow (current US$) of Afghanistan in 2005 to that in 2009?
Your answer should be compact. 2.04. What is the ratio of the Aid flow (current US$) of Least developed countries in 2005 to that in 2010?
Ensure brevity in your answer.  0.76. What is the ratio of the Aid flow (current US$) in Other small states in 2005 to that in 2010?
Your answer should be compact. 0.53. What is the ratio of the Aid flow (current US$) of Afghanistan in 2005 to that in 2010?
Offer a terse response. 2.29. What is the ratio of the Aid flow (current US$) of Arab World in 2005 to that in 2011?
Provide a succinct answer. 0.98. What is the ratio of the Aid flow (current US$) in Least developed countries in 2005 to that in 2011?
Make the answer very short. 0.85. What is the ratio of the Aid flow (current US$) in Other small states in 2005 to that in 2011?
Make the answer very short. 2.62. What is the ratio of the Aid flow (current US$) in Afghanistan in 2005 to that in 2011?
Your answer should be very brief. 2.22. What is the ratio of the Aid flow (current US$) in Arab World in 2005 to that in 2012?
Make the answer very short. 0.89. What is the ratio of the Aid flow (current US$) in Least developed countries in 2005 to that in 2012?
Provide a short and direct response. 0.83. What is the ratio of the Aid flow (current US$) in Other small states in 2005 to that in 2012?
Offer a very short reply. 13.6. What is the ratio of the Aid flow (current US$) in Afghanistan in 2005 to that in 2012?
Give a very brief answer. 3.2. What is the ratio of the Aid flow (current US$) in Arab World in 2006 to that in 2007?
Keep it short and to the point. 0.14. What is the ratio of the Aid flow (current US$) of Least developed countries in 2006 to that in 2007?
Provide a succinct answer. 0.87. What is the ratio of the Aid flow (current US$) of Other small states in 2006 to that in 2007?
Provide a short and direct response. 1.29. What is the ratio of the Aid flow (current US$) in Arab World in 2006 to that in 2008?
Offer a very short reply. 0.06. What is the ratio of the Aid flow (current US$) of Least developed countries in 2006 to that in 2008?
Your response must be concise. 0.82. What is the ratio of the Aid flow (current US$) in Other small states in 2006 to that in 2008?
Your response must be concise. 0.68. What is the ratio of the Aid flow (current US$) in Afghanistan in 2006 to that in 2008?
Keep it short and to the point. 1.65. What is the ratio of the Aid flow (current US$) in Arab World in 2006 to that in 2009?
Provide a short and direct response. 0.07. What is the ratio of the Aid flow (current US$) in Least developed countries in 2006 to that in 2009?
Keep it short and to the point. 1.08. What is the ratio of the Aid flow (current US$) of Other small states in 2006 to that in 2009?
Offer a terse response. 0.6. What is the ratio of the Aid flow (current US$) in Afghanistan in 2006 to that in 2009?
Offer a terse response. 3.09. What is the ratio of the Aid flow (current US$) in Arab World in 2006 to that in 2010?
Your answer should be compact. 0.13. What is the ratio of the Aid flow (current US$) in Least developed countries in 2006 to that in 2010?
Provide a succinct answer. 1.18. What is the ratio of the Aid flow (current US$) of Other small states in 2006 to that in 2010?
Provide a short and direct response. 0.79. What is the ratio of the Aid flow (current US$) in Afghanistan in 2006 to that in 2010?
Your answer should be very brief. 3.48. What is the ratio of the Aid flow (current US$) of Arab World in 2006 to that in 2011?
Make the answer very short. 0.11. What is the ratio of the Aid flow (current US$) of Least developed countries in 2006 to that in 2011?
Your answer should be very brief. 1.32. What is the ratio of the Aid flow (current US$) of Other small states in 2006 to that in 2011?
Provide a succinct answer. 3.88. What is the ratio of the Aid flow (current US$) of Afghanistan in 2006 to that in 2011?
Your response must be concise. 3.37. What is the ratio of the Aid flow (current US$) of Arab World in 2006 to that in 2012?
Offer a terse response. 0.1. What is the ratio of the Aid flow (current US$) in Least developed countries in 2006 to that in 2012?
Your response must be concise. 1.29. What is the ratio of the Aid flow (current US$) of Other small states in 2006 to that in 2012?
Provide a short and direct response. 20.2. What is the ratio of the Aid flow (current US$) in Afghanistan in 2006 to that in 2012?
Keep it short and to the point. 4.86. What is the ratio of the Aid flow (current US$) of Arab World in 2007 to that in 2008?
Ensure brevity in your answer.  0.4. What is the ratio of the Aid flow (current US$) of Least developed countries in 2007 to that in 2008?
Make the answer very short. 0.95. What is the ratio of the Aid flow (current US$) in Other small states in 2007 to that in 2008?
Your answer should be very brief. 0.52. What is the ratio of the Aid flow (current US$) of Afghanistan in 2007 to that in 2008?
Offer a terse response. 1.71. What is the ratio of the Aid flow (current US$) in Arab World in 2007 to that in 2009?
Make the answer very short. 0.51. What is the ratio of the Aid flow (current US$) of Least developed countries in 2007 to that in 2009?
Offer a very short reply. 1.25. What is the ratio of the Aid flow (current US$) of Other small states in 2007 to that in 2009?
Provide a succinct answer. 0.47. What is the ratio of the Aid flow (current US$) of Afghanistan in 2007 to that in 2009?
Your answer should be very brief. 3.21. What is the ratio of the Aid flow (current US$) in Arab World in 2007 to that in 2010?
Provide a short and direct response. 0.92. What is the ratio of the Aid flow (current US$) of Least developed countries in 2007 to that in 2010?
Ensure brevity in your answer.  1.35. What is the ratio of the Aid flow (current US$) in Other small states in 2007 to that in 2010?
Your answer should be compact. 0.61. What is the ratio of the Aid flow (current US$) in Afghanistan in 2007 to that in 2010?
Provide a succinct answer. 3.61. What is the ratio of the Aid flow (current US$) in Arab World in 2007 to that in 2011?
Your answer should be very brief. 0.75. What is the ratio of the Aid flow (current US$) of Least developed countries in 2007 to that in 2011?
Provide a short and direct response. 1.52. What is the ratio of the Aid flow (current US$) in Afghanistan in 2007 to that in 2011?
Ensure brevity in your answer.  3.5. What is the ratio of the Aid flow (current US$) in Arab World in 2007 to that in 2012?
Provide a short and direct response. 0.69. What is the ratio of the Aid flow (current US$) of Least developed countries in 2007 to that in 2012?
Your response must be concise. 1.48. What is the ratio of the Aid flow (current US$) in Other small states in 2007 to that in 2012?
Your answer should be compact. 15.6. What is the ratio of the Aid flow (current US$) in Afghanistan in 2007 to that in 2012?
Make the answer very short. 5.04. What is the ratio of the Aid flow (current US$) of Arab World in 2008 to that in 2009?
Make the answer very short. 1.27. What is the ratio of the Aid flow (current US$) in Least developed countries in 2008 to that in 2009?
Give a very brief answer. 1.32. What is the ratio of the Aid flow (current US$) of Other small states in 2008 to that in 2009?
Your answer should be very brief. 0.89. What is the ratio of the Aid flow (current US$) in Afghanistan in 2008 to that in 2009?
Offer a terse response. 1.87. What is the ratio of the Aid flow (current US$) of Arab World in 2008 to that in 2010?
Offer a very short reply. 2.3. What is the ratio of the Aid flow (current US$) in Least developed countries in 2008 to that in 2010?
Your answer should be compact. 1.43. What is the ratio of the Aid flow (current US$) in Other small states in 2008 to that in 2010?
Your response must be concise. 1.16. What is the ratio of the Aid flow (current US$) of Afghanistan in 2008 to that in 2010?
Your answer should be very brief. 2.11. What is the ratio of the Aid flow (current US$) in Arab World in 2008 to that in 2011?
Make the answer very short. 1.88. What is the ratio of the Aid flow (current US$) in Least developed countries in 2008 to that in 2011?
Your answer should be very brief. 1.61. What is the ratio of the Aid flow (current US$) in Other small states in 2008 to that in 2011?
Make the answer very short. 5.73. What is the ratio of the Aid flow (current US$) in Afghanistan in 2008 to that in 2011?
Provide a succinct answer. 2.05. What is the ratio of the Aid flow (current US$) of Arab World in 2008 to that in 2012?
Provide a succinct answer. 1.72. What is the ratio of the Aid flow (current US$) in Least developed countries in 2008 to that in 2012?
Your answer should be compact. 1.57. What is the ratio of the Aid flow (current US$) of Other small states in 2008 to that in 2012?
Provide a succinct answer. 29.8. What is the ratio of the Aid flow (current US$) in Afghanistan in 2008 to that in 2012?
Your response must be concise. 2.95. What is the ratio of the Aid flow (current US$) of Arab World in 2009 to that in 2010?
Offer a terse response. 1.82. What is the ratio of the Aid flow (current US$) of Least developed countries in 2009 to that in 2010?
Provide a short and direct response. 1.09. What is the ratio of the Aid flow (current US$) in Other small states in 2009 to that in 2010?
Keep it short and to the point. 1.3. What is the ratio of the Aid flow (current US$) of Afghanistan in 2009 to that in 2010?
Give a very brief answer. 1.13. What is the ratio of the Aid flow (current US$) of Arab World in 2009 to that in 2011?
Provide a succinct answer. 1.48. What is the ratio of the Aid flow (current US$) of Least developed countries in 2009 to that in 2011?
Provide a succinct answer. 1.22. What is the ratio of the Aid flow (current US$) in Other small states in 2009 to that in 2011?
Your answer should be compact. 6.42. What is the ratio of the Aid flow (current US$) of Afghanistan in 2009 to that in 2011?
Give a very brief answer. 1.09. What is the ratio of the Aid flow (current US$) of Arab World in 2009 to that in 2012?
Your response must be concise. 1.35. What is the ratio of the Aid flow (current US$) of Least developed countries in 2009 to that in 2012?
Provide a short and direct response. 1.19. What is the ratio of the Aid flow (current US$) in Other small states in 2009 to that in 2012?
Your answer should be very brief. 33.4. What is the ratio of the Aid flow (current US$) in Afghanistan in 2009 to that in 2012?
Ensure brevity in your answer.  1.57. What is the ratio of the Aid flow (current US$) of Arab World in 2010 to that in 2011?
Keep it short and to the point. 0.81. What is the ratio of the Aid flow (current US$) of Least developed countries in 2010 to that in 2011?
Offer a terse response. 1.12. What is the ratio of the Aid flow (current US$) of Other small states in 2010 to that in 2011?
Offer a terse response. 4.94. What is the ratio of the Aid flow (current US$) in Afghanistan in 2010 to that in 2011?
Give a very brief answer. 0.97. What is the ratio of the Aid flow (current US$) of Arab World in 2010 to that in 2012?
Keep it short and to the point. 0.74. What is the ratio of the Aid flow (current US$) in Least developed countries in 2010 to that in 2012?
Ensure brevity in your answer.  1.1. What is the ratio of the Aid flow (current US$) in Other small states in 2010 to that in 2012?
Your answer should be compact. 25.7. What is the ratio of the Aid flow (current US$) of Afghanistan in 2010 to that in 2012?
Provide a short and direct response. 1.4. What is the ratio of the Aid flow (current US$) of Arab World in 2011 to that in 2012?
Offer a very short reply. 0.91. What is the ratio of the Aid flow (current US$) of Least developed countries in 2011 to that in 2012?
Give a very brief answer. 0.97. What is the ratio of the Aid flow (current US$) in Other small states in 2011 to that in 2012?
Provide a succinct answer. 5.2. What is the ratio of the Aid flow (current US$) in Afghanistan in 2011 to that in 2012?
Offer a very short reply. 1.44. What is the difference between the highest and the second highest Aid flow (current US$) in Arab World?
Offer a terse response. 5.10e+05. What is the difference between the highest and the second highest Aid flow (current US$) in Least developed countries?
Make the answer very short. 8.60e+05. What is the difference between the highest and the second highest Aid flow (current US$) of Other small states?
Provide a succinct answer. 3.60e+05. What is the difference between the highest and the lowest Aid flow (current US$) in Arab World?
Provide a short and direct response. 2.28e+06. What is the difference between the highest and the lowest Aid flow (current US$) of Least developed countries?
Your response must be concise. 7.46e+06. What is the difference between the highest and the lowest Aid flow (current US$) in Other small states?
Provide a succinct answer. 3.24e+06. What is the difference between the highest and the lowest Aid flow (current US$) of Afghanistan?
Give a very brief answer. 3.68e+06. 